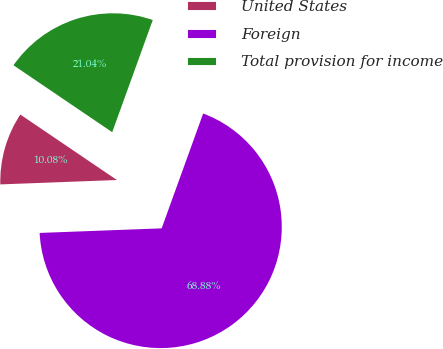Convert chart. <chart><loc_0><loc_0><loc_500><loc_500><pie_chart><fcel>United States<fcel>Foreign<fcel>Total provision for income<nl><fcel>10.08%<fcel>68.88%<fcel>21.04%<nl></chart> 